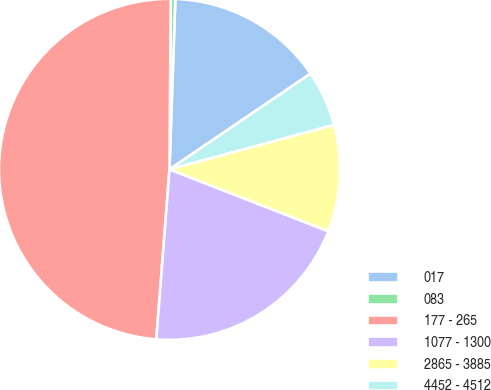<chart> <loc_0><loc_0><loc_500><loc_500><pie_chart><fcel>017<fcel>083<fcel>177 - 265<fcel>1077 - 1300<fcel>2865 - 3885<fcel>4452 - 4512<nl><fcel>14.97%<fcel>0.43%<fcel>48.89%<fcel>20.32%<fcel>10.12%<fcel>5.28%<nl></chart> 